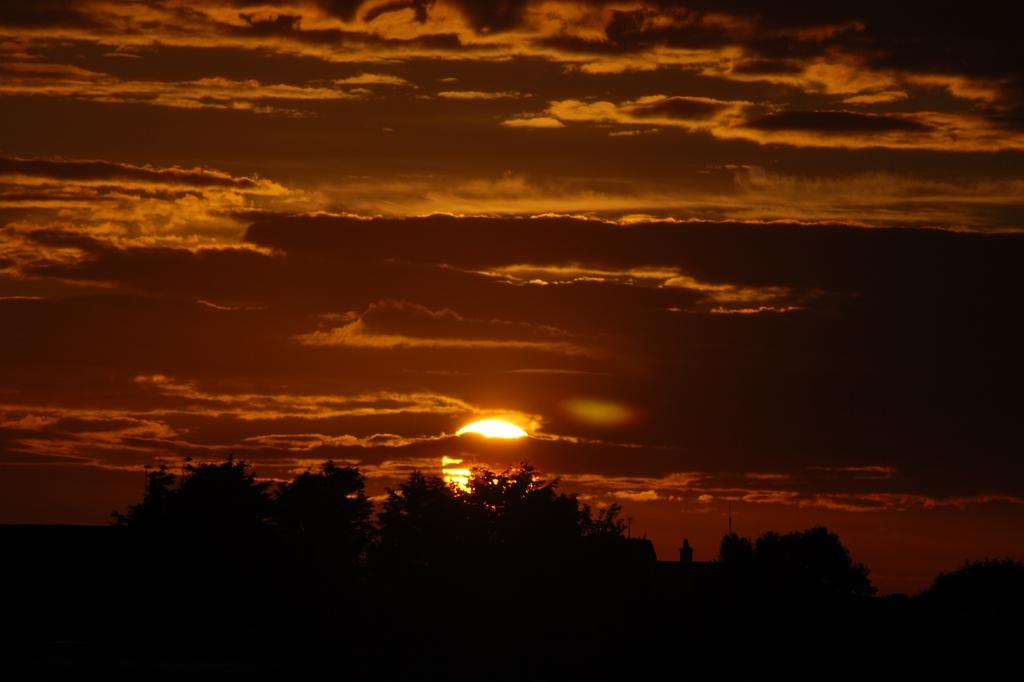What is located in the center of the image? There are trees in the center of the image. How would you describe the sky in the image? The sky is cloudy in the image. Can you see the sun in the image? Yes, the sun is visible in the sky in the background of the image. Where is the rabbit grazing in the garden in the image? There is no rabbit or garden present in the image; it features trees and a cloudy sky. 